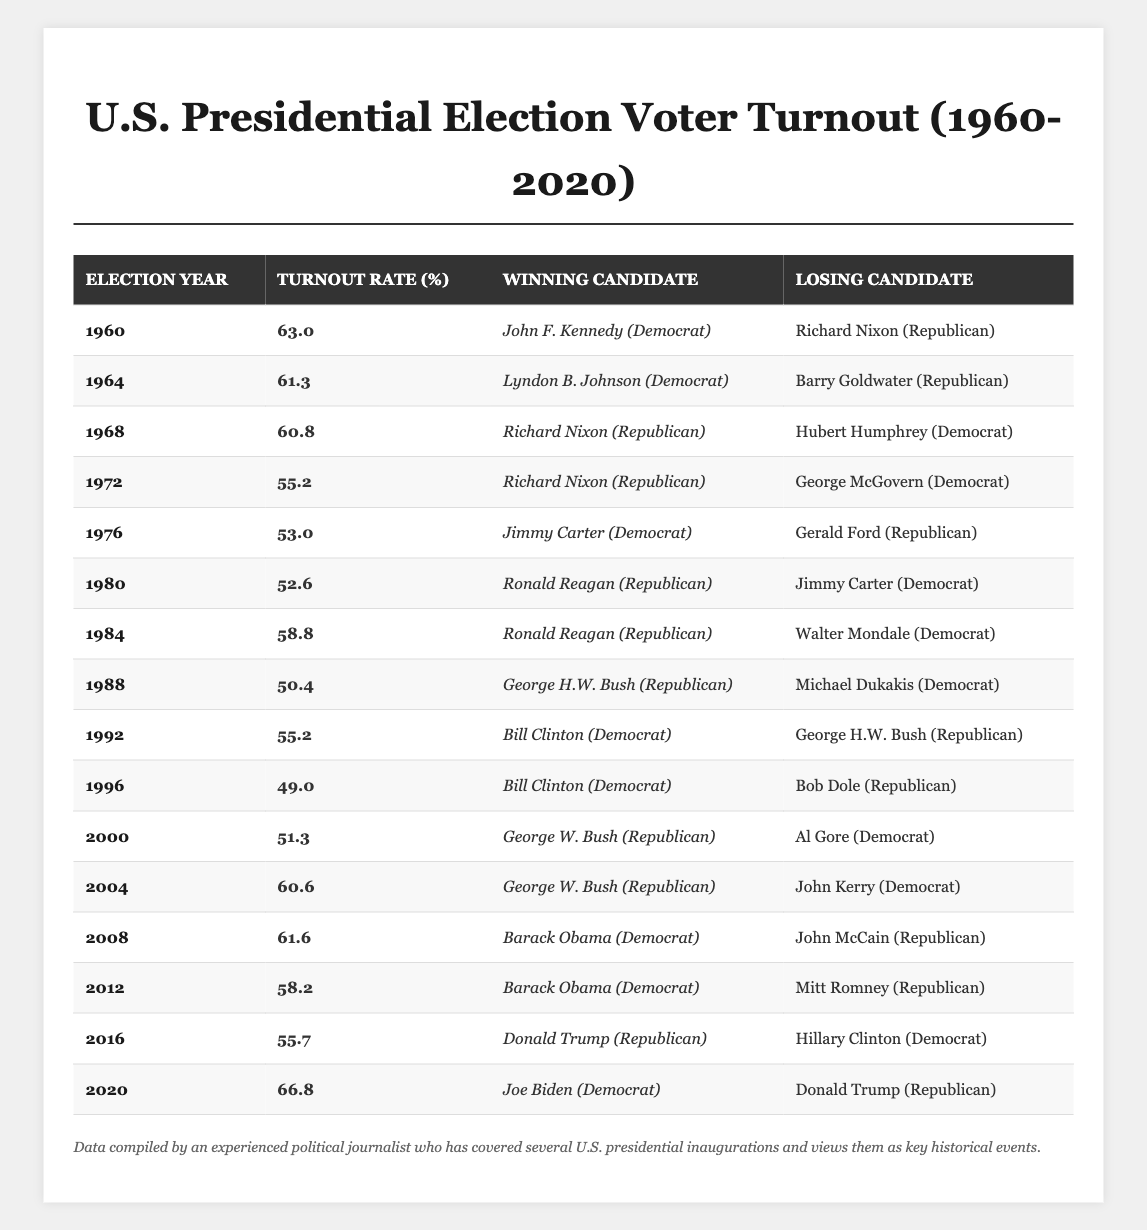What was the voter turnout rate in 2004? The table shows the turnout rate for each election year. In 2004, the turnout rate is listed as 60.6%.
Answer: 60.6% Which candidate won in 1968? According to the table, Richard Nixon (Republican) is indicated as the winning candidate for the election year 1968.
Answer: Richard Nixon (Republican) What is the difference in voter turnout between 2000 and 2004? The turnout rate for 2000 is 51.3% and for 2004 it is 60.6%. The difference is calculated as 60.6% - 51.3% = 9.3%.
Answer: 9.3% What percentage of voter turnout was above 60%? Counting the turnout rates listed, the years with rates above 60% are: 1960 (63.0%), 1964 (61.3%), 2004 (60.6%), 2008 (61.6%), 2012 (58.2%), and 2020 (66.8%). The above-60% rates occur in 5 out of the 16 years.
Answer: 5 years Did any Republican candidates win with a turnout rate lower than 55%? The table shows Nixon won in 1972 (55.2%) and in 1988 (50.4%) with turnout rates below 55%. Thus, yes, there are instances where Republican candidates won with a turnout rate lower than 55%.
Answer: Yes What is the average voter turnout rate from 1960 to 2020? To find the average, sum the turnout rates across all years: (63.0 + 61.3 + 60.8 + 55.2 + 53.0 + 52.6 + 58.8 + 50.4 + 55.2 + 49.0 + 51.3 + 60.6 + 61.6 + 58.2 + 55.7 + 66.8) = 941.0. Divide by the number of years (16), which gives an average of 941.0/16 = 58.8125.
Answer: 58.81 How many election years experienced a voter turnout below 55%? Referring to the table, the years with turnout rates below 55% are 1972 (55.2%), 1976 (53.0%), 1980 (52.6%), 1988 (50.4%), 1996 (49.0%). That totals to 5 years.
Answer: 5 years Which election had the highest voter turnout rate? The highest turnout rate is found in 2020, with a turnout of 66.8%.
Answer: 2020 Which winning candidate had the lowest turnout rate? The lowest turnout rate occurs in the election won by Ronald Reagan in 1988 at 50.4%.
Answer: Ronald Reagan (1988) Was there ever a year where the winning candidate was a Democrat, and the turnout was below 55%? Looking at the table, Jimmy Carter (Democrat) won in 1976 (53.0%) which is below 55%. Hence, yes.
Answer: Yes What is the trend in voter turnout from 1960 to 2020? Observing the turnout rates over the years, I can note a general decline in the 1970s and 1980s, reaching a low in 1988 before fluctuating in the following decades and ultimately increasing significantly in 2020. Overall, we see an increase in turnout towards the latter half of the time period.
Answer: Increasing trend overall, especially in the latter years 